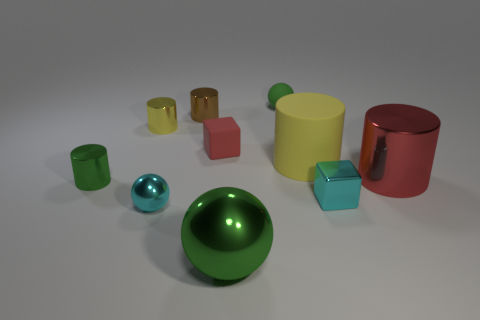Subtract all red metal cylinders. How many cylinders are left? 4 Subtract all cyan cylinders. Subtract all red blocks. How many cylinders are left? 5 Subtract all balls. How many objects are left? 7 Subtract 1 cyan spheres. How many objects are left? 9 Subtract all big cylinders. Subtract all big metallic cylinders. How many objects are left? 7 Add 4 small red blocks. How many small red blocks are left? 5 Add 7 small brown shiny cylinders. How many small brown shiny cylinders exist? 8 